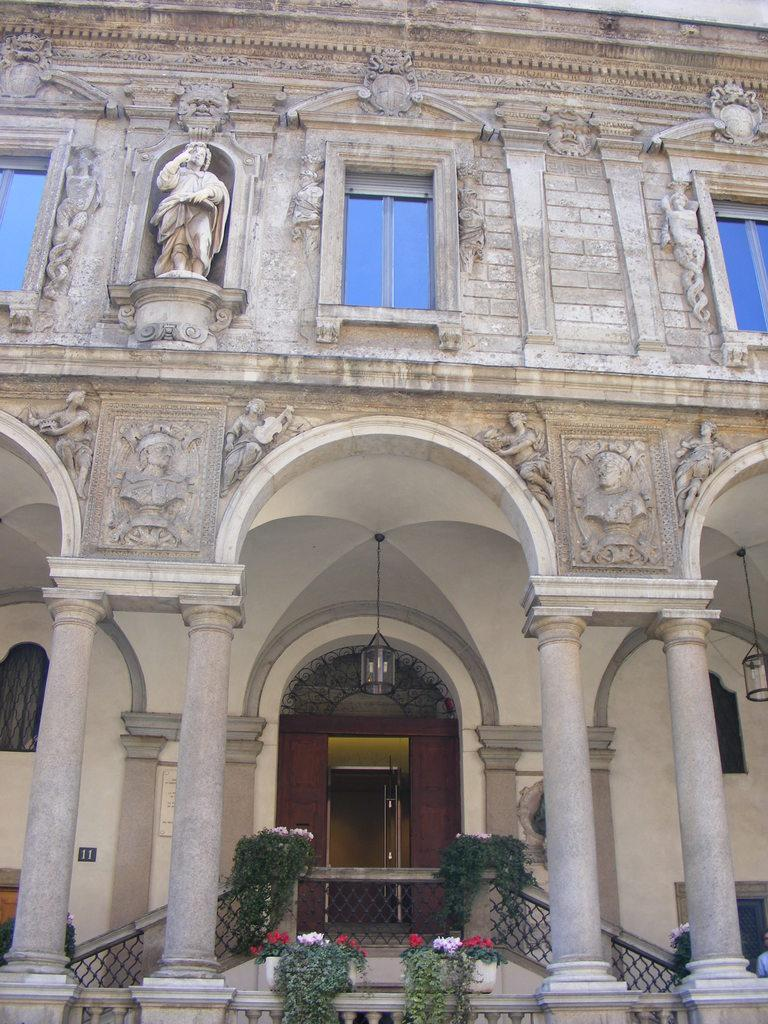What type of structure is visible in the image? There is a building in the image. What architectural features can be seen on the building? There are pillars, windows, lights, and railings visible in the image. What decorative elements are present in the image? There are flowers, plants, and statues in the image. What type of fork can be seen in the image? There is no fork present in the image; it features a building with various architectural and decorative elements. 